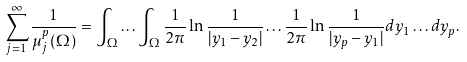Convert formula to latex. <formula><loc_0><loc_0><loc_500><loc_500>\sum _ { j = 1 } ^ { \infty } \frac { 1 } { \mu _ { j } ^ { p } ( \Omega ) } = \int _ { \Omega } \dots \int _ { \Omega } \frac { 1 } { 2 \pi } \ln \frac { 1 } { | y _ { 1 } - y _ { 2 } | } \dots \frac { 1 } { 2 \pi } \ln \frac { 1 } { | y _ { p } - y _ { 1 } | } d y _ { 1 } \dots d y _ { p } .</formula> 